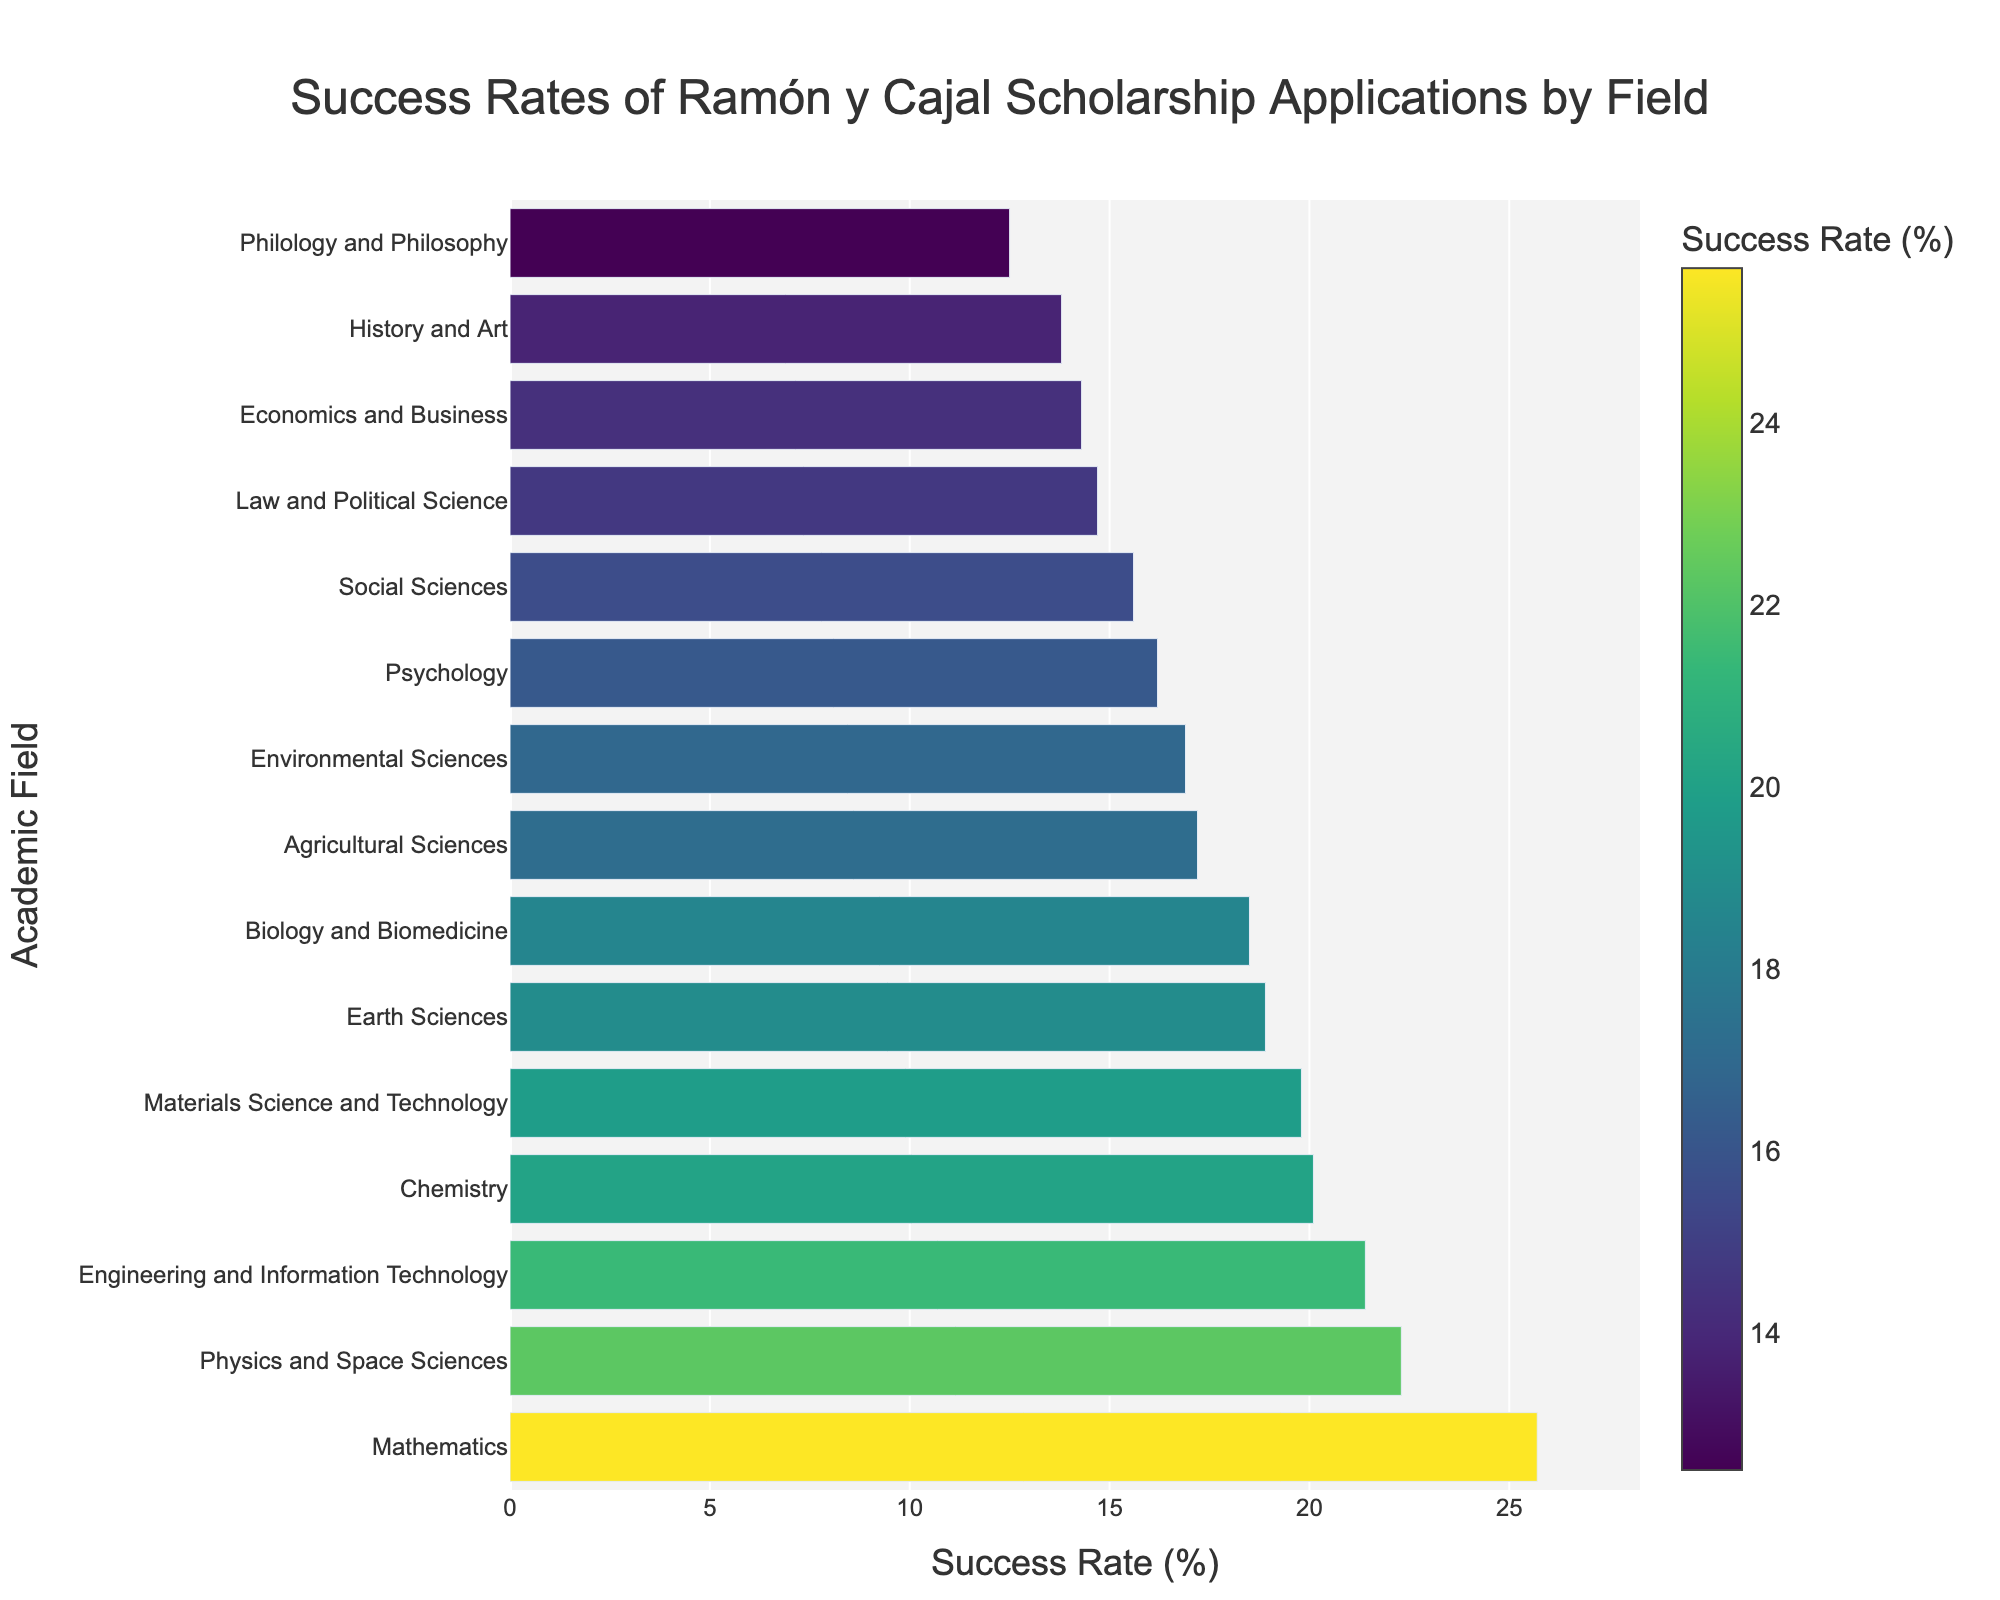Which academic field has the highest success rate for Ramón y Cajal scholarship applications? To find the field with the highest success rate, look for the bar that extends the furthest to the right. The "Mathematics" field has the highest success rate at 25.7%.
Answer: Mathematics Which academic field has the lowest success rate? To identify the academic field with the lowest success rate, find the shortest bar on the chart. The "Philology and Philosophy" field has the lowest success rate at 12.5%.
Answer: Philology and Philosophy What is the difference in success rate between Physics and Space Sciences and Chemistry? Locate the bars for "Physics and Space Sciences" and "Chemistry". Subtract the success rate of Chemistry (20.1%) from that of Physics and Space Sciences (22.3%). \(22.3 - 20.1 = 2.2\%\)
Answer: 2.2% Which academic fields have a success rate greater than 20%? Find all the fields with bars extending beyond the 20% mark. These fields are "Physics and Space Sciences" (22.3%), "Mathematics" (25.7%), and "Chemistry" (20.1%).
Answer: Physics and Space Sciences, Mathematics, Chemistry What is the average success rate across all academic fields? To find the average, sum all the success rates and divide by the number of fields. The total sum is \(18.5 + 22.3 + 25.7 + 20.1 + 19.8 + 15.6 + 17.2 + 21.4 + 16.9 + 14.3 + 13.8 + 12.5 + 14.7 + 16.2 + 18.9 = 268.9\). There are 15 fields. \(268.9 / 15 \approx 17.93%\)
Answer: 17.93% Compare the success rate of Engineering and Information Technology with Earth Sciences. Which one is higher and by how much? Locate the bars for "Engineering and Information Technology" (21.4%) and "Earth Sciences" (18.9%). Subtract the success rate of Earth Sciences from that of Engineering and Information Technology. \(21.4 - 18.9 = 2.5\%\)
Answer: Engineering and Information Technology is higher by 2.5% What is the combined success rate of Agricultural Sciences and Environmental Sciences? Sum the success rates of "Agricultural Sciences" (17.2%) and "Environmental Sciences" (16.9%). \(17.2 + 16.9 = 34.1\%\)
Answer: 34.1% How many fields have success rates between 15% and 20%? Count all the fields whose success rates fall between 15% and 20%. These fields are "Biology and Biomedicine" (18.5%), "Materials Science and Technology" (19.8%), "Social Sciences" (15.6%), "Agricultural Sciences" (17.2%), "Environmental Sciences" (16.9%), "Psychology" (16.2%), and "Earth Sciences" (18.9%). There are 7 such fields.
Answer: 7 Which field shows a visually noticeable darker shade in the bar chart? Bars with higher success rates are shown in darker shades due to the color scale. The field "Mathematics" shows the darkest shade in the bar chart.
Answer: Mathematics 